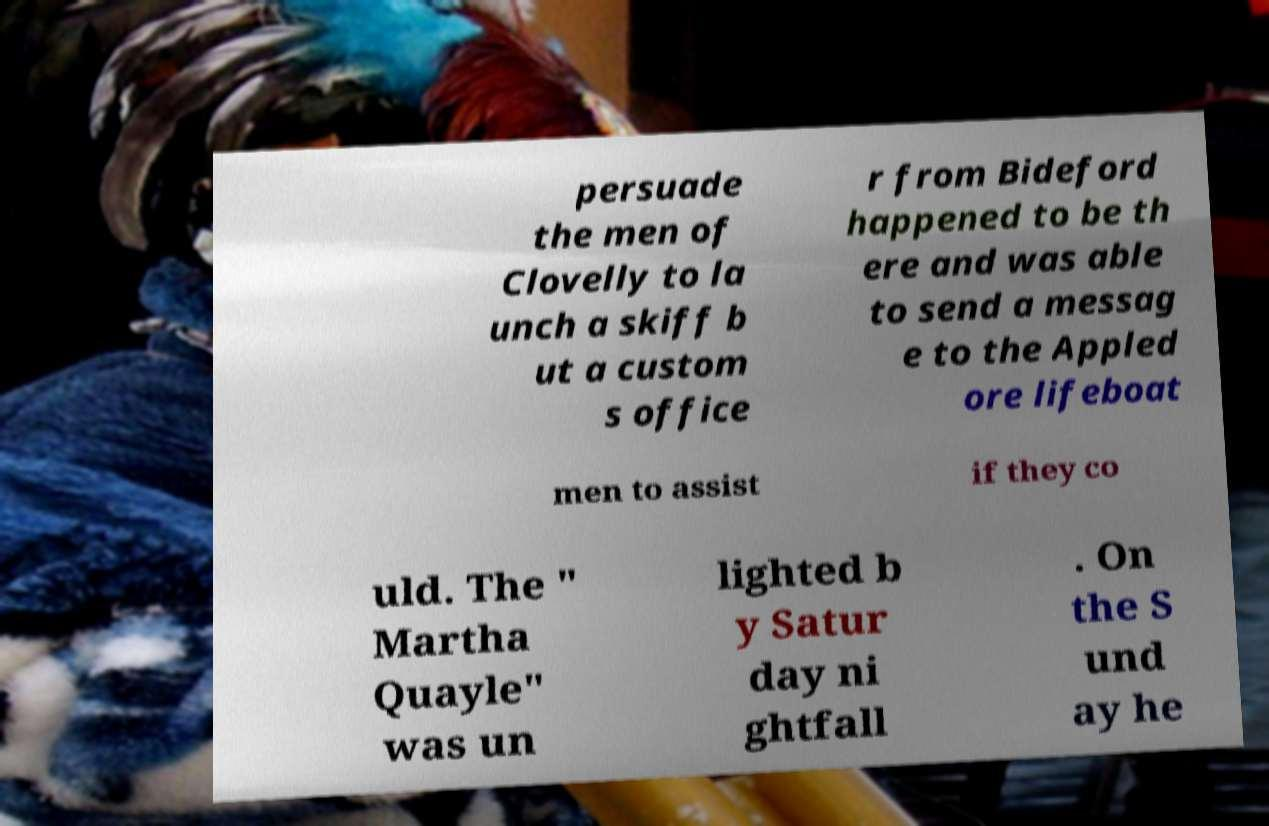What messages or text are displayed in this image? I need them in a readable, typed format. persuade the men of Clovelly to la unch a skiff b ut a custom s office r from Bideford happened to be th ere and was able to send a messag e to the Appled ore lifeboat men to assist if they co uld. The " Martha Quayle" was un lighted b y Satur day ni ghtfall . On the S und ay he 